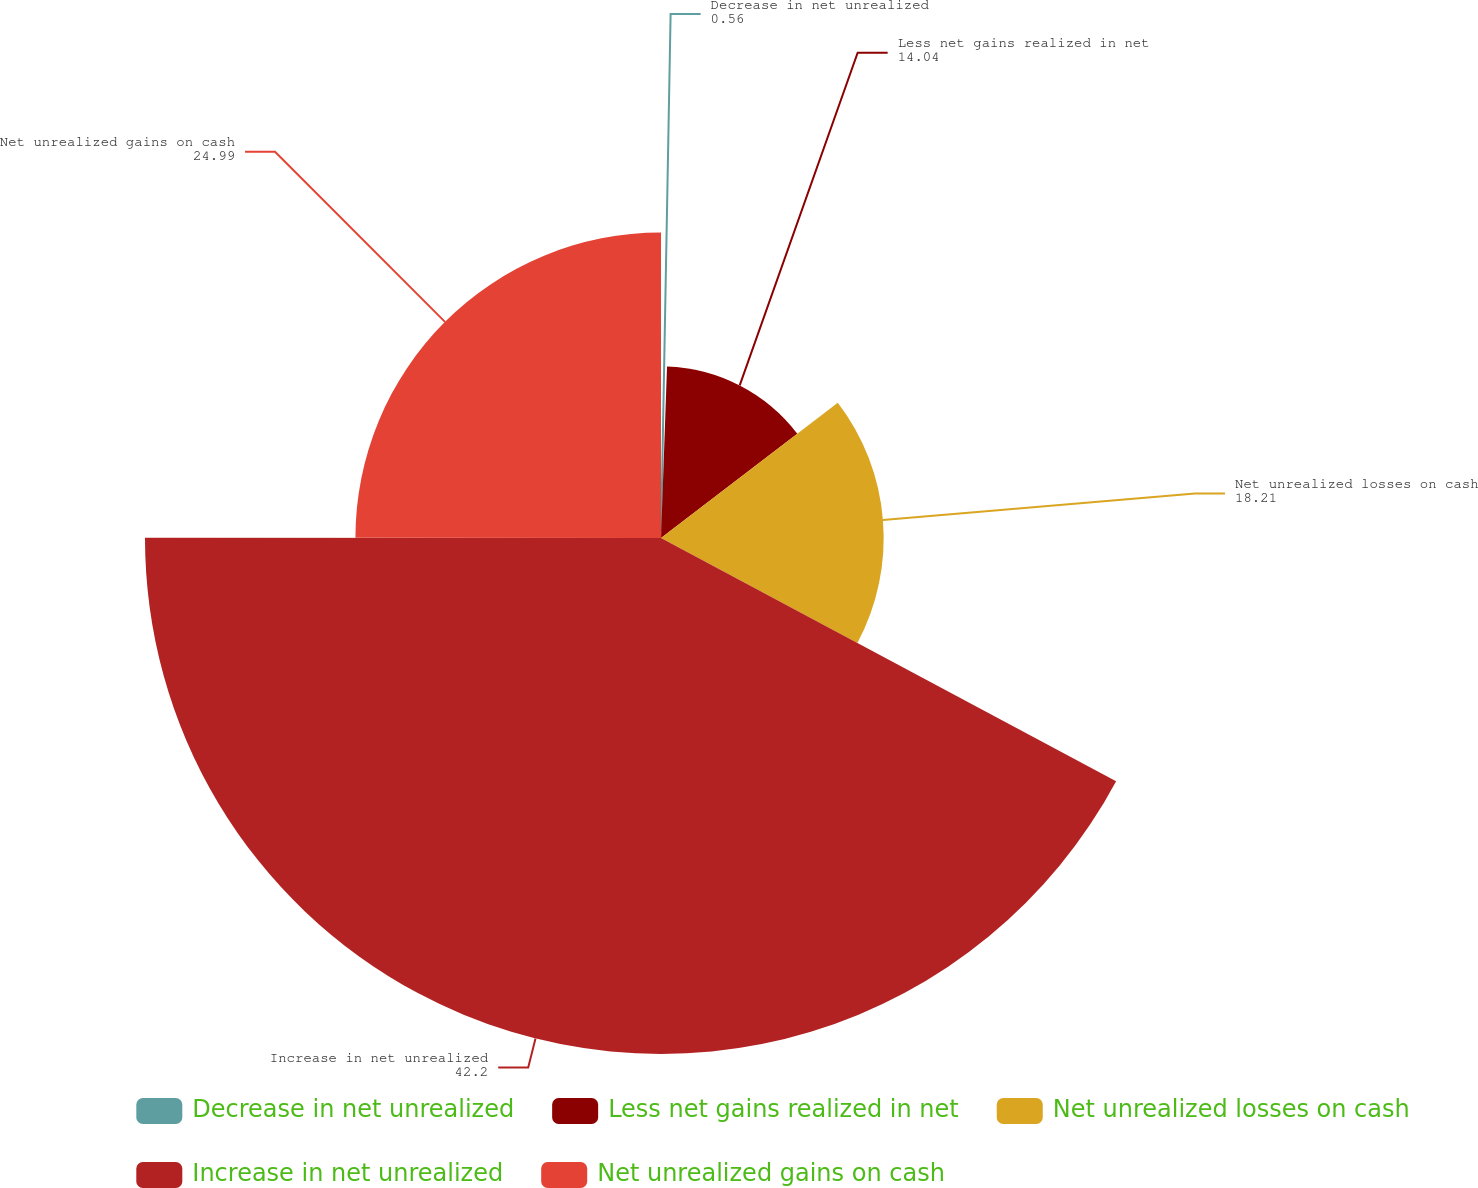Convert chart to OTSL. <chart><loc_0><loc_0><loc_500><loc_500><pie_chart><fcel>Decrease in net unrealized<fcel>Less net gains realized in net<fcel>Net unrealized losses on cash<fcel>Increase in net unrealized<fcel>Net unrealized gains on cash<nl><fcel>0.56%<fcel>14.04%<fcel>18.21%<fcel>42.2%<fcel>24.99%<nl></chart> 